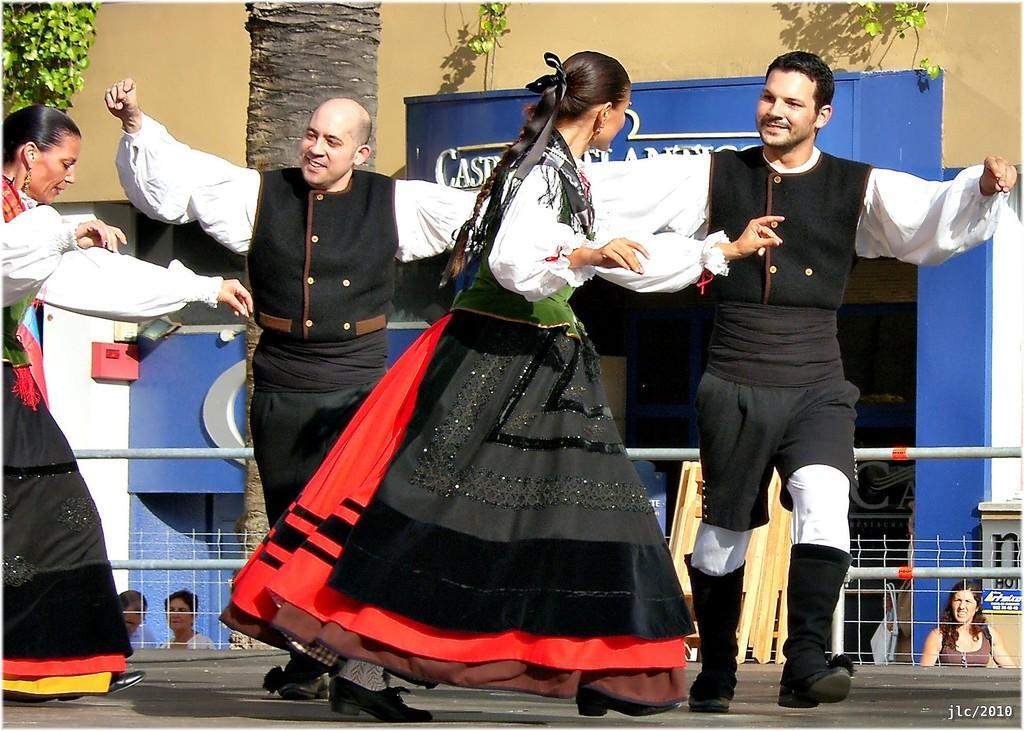What are the people in the image doing? The people in the image are dancing. Where are the people dancing? The people are dancing on the floor. What can be seen in the background of the image? There is a tree visible in the image. What type of barrier is present in the image? There is a metal grill fence in the image. How many women are dancing in the image? There is no mention of a woman in the image, so it is not possible to determine the number of women dancing. 